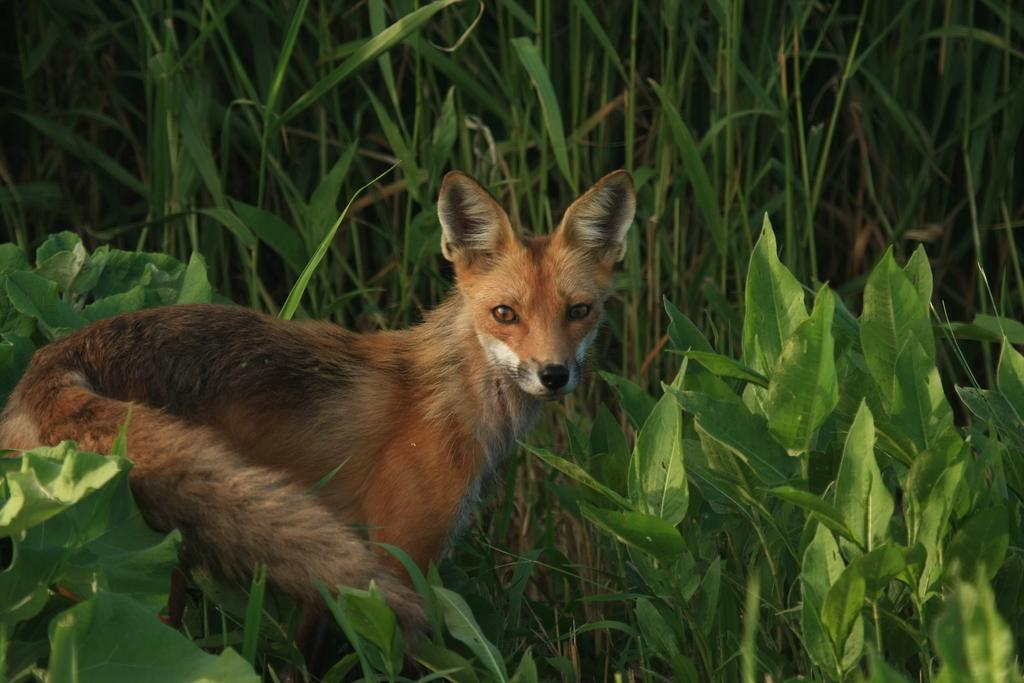What is located at the bottom of the image? There are plants at the bottom of the image. What animal can be seen on the left side of the image? There is a fox standing on the ground on the left side of the image. What type of vegetation is visible in the background of the image? There are plants in the background of the image. Can you tell me how many guides are leading the flock of animals in the image? There are no guides or flocks of animals present in the image; it features a fox and plants. What type of cake is being served on the right side of the image? There is no cake present in the image; it features a fox and plants. 